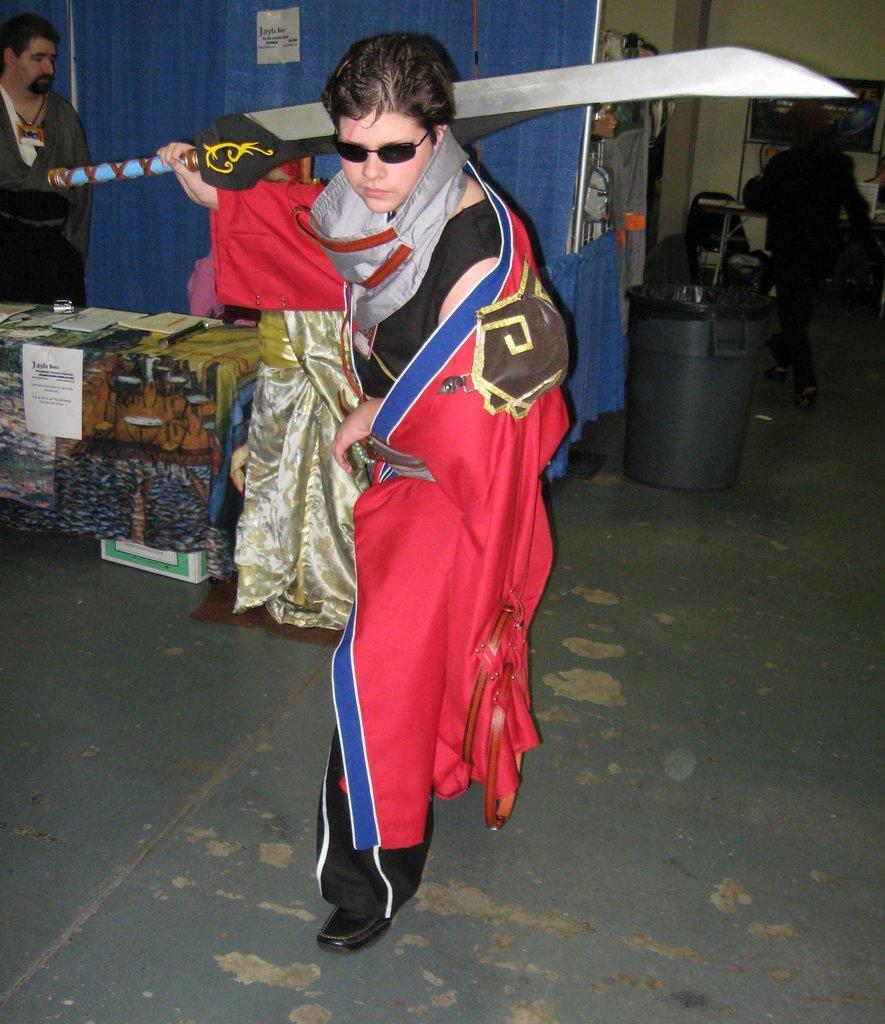Please provide a concise description of this image. This is the man standing and holding a sword. I think this is a table, which is covered with a cloth. I can see the papers and few other things on it. On the left side of the image, I can see another person standing. I think this is a dustbin. These look like the clothes, which are blue in color. On the right side of the image, I can see a person walking. This is the floor. 